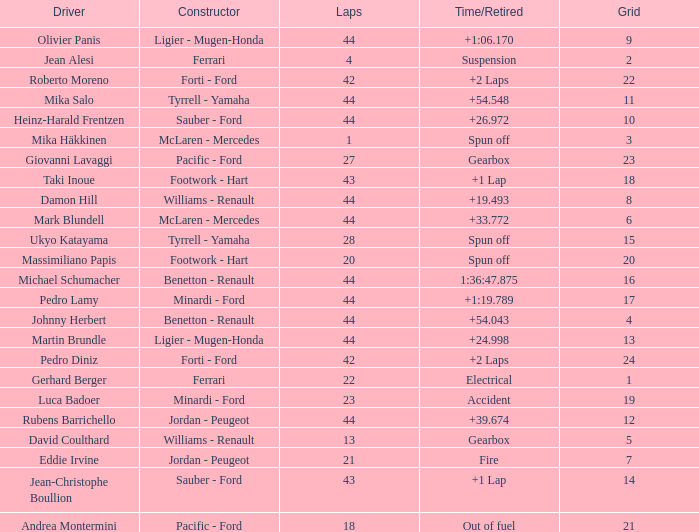What is the high lap total for cards with a grid larger than 21, and a Time/Retired of +2 laps? 42.0. 